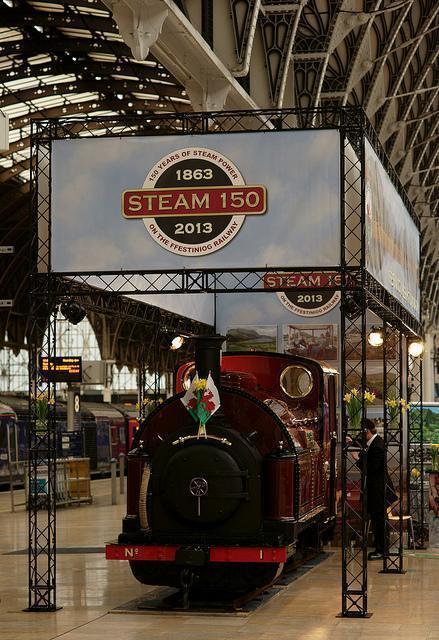Which anniversary is being celebrated?
Choose the right answer and clarify with the format: 'Answer: answer
Rationale: rationale.'
Options: 150, 2013, 100, 1863. Answer: 150.
Rationale: The celebration is a 150th anniversary as shown by the number. What operation should be done with the numbers to arrive at the years of steam power?
Select the accurate response from the four choices given to answer the question.
Options: Division, multiplication, subtraction, addition. Subtraction. 